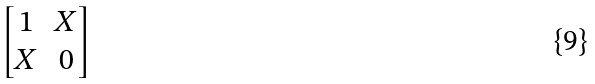Convert formula to latex. <formula><loc_0><loc_0><loc_500><loc_500>\begin{bmatrix} 1 & X \\ X & 0 \end{bmatrix}</formula> 